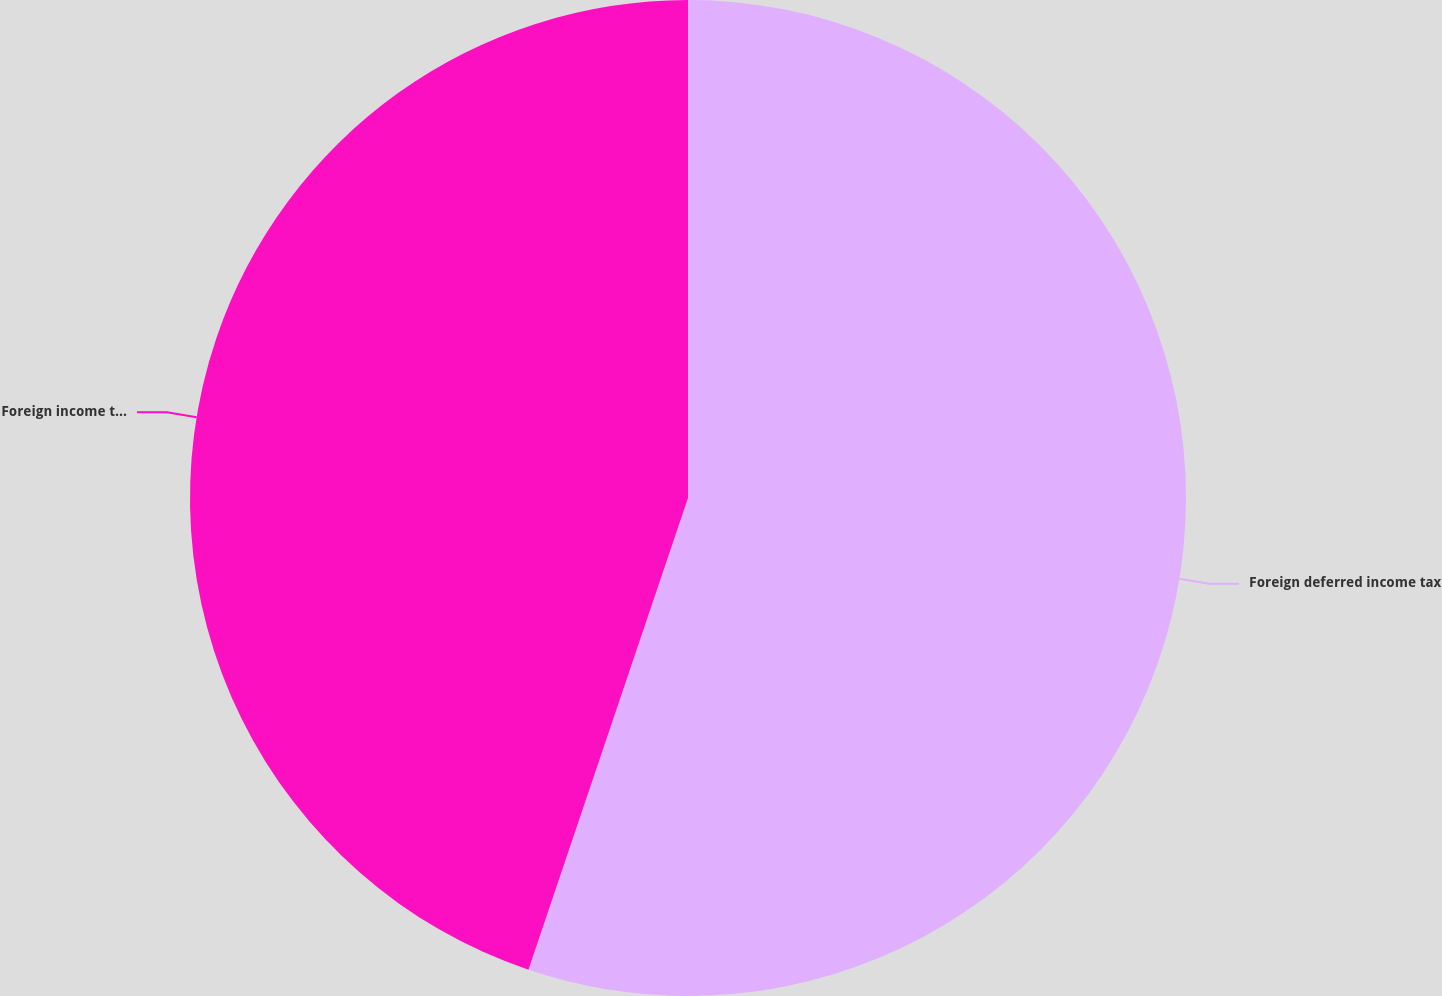<chart> <loc_0><loc_0><loc_500><loc_500><pie_chart><fcel>Foreign deferred income tax<fcel>Foreign income tax credit<nl><fcel>55.19%<fcel>44.81%<nl></chart> 